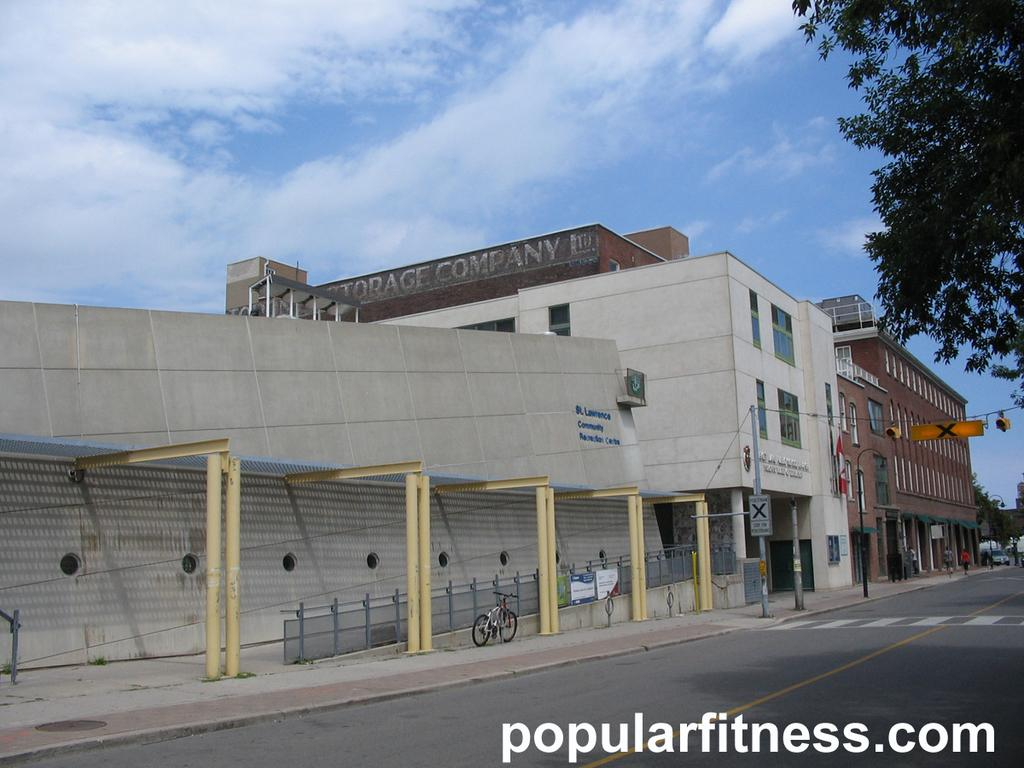What type of structures can be seen in the image? There are buildings in the image. What mode of transportation is present in the image? There is a bicycle in the image. What type of vegetation is in the image? There is a tree in the image. What type of pathway is visible in the image? There is a road in the image. What part of the natural environment is visible in the image? The sky is visible in the image. What type of fear can be seen on the faces of the people in the image? There are no people present in the image, so it is not possible to determine if they are experiencing any fear. What type of country is depicted in the image? The image does not depict a specific country; it shows buildings, a bicycle, a tree, a road, and the sky. What type of fruit is being harvested from the tree in the image? There is no fruit being harvested from the tree in the image; it is a single tree without any visible fruit. 